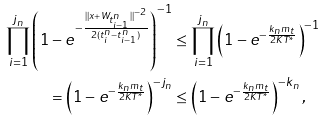Convert formula to latex. <formula><loc_0><loc_0><loc_500><loc_500>\prod _ { i = 1 } ^ { j _ { n } } \left ( 1 - e ^ { - \frac { \| x + W _ { t ^ { n } _ { i - 1 } } \| ^ { - 2 } } { 2 ( t ^ { n } _ { i } - t ^ { n } _ { i - 1 } ) } } \right ) ^ { - 1 } & \leq \prod _ { i = 1 } ^ { j _ { n } } \left ( 1 - e ^ { - \frac { k _ { n } m _ { t } } { 2 K T ^ { * } } } \right ) ^ { - 1 } \\ = \left ( 1 - e ^ { - \frac { k _ { n } m _ { t } } { 2 K T ^ { * } } } \right ) ^ { - j _ { n } } & \leq \left ( 1 - e ^ { - \frac { k _ { n } m _ { t } } { 2 K T ^ { * } } } \right ) ^ { - k _ { n } } ,</formula> 